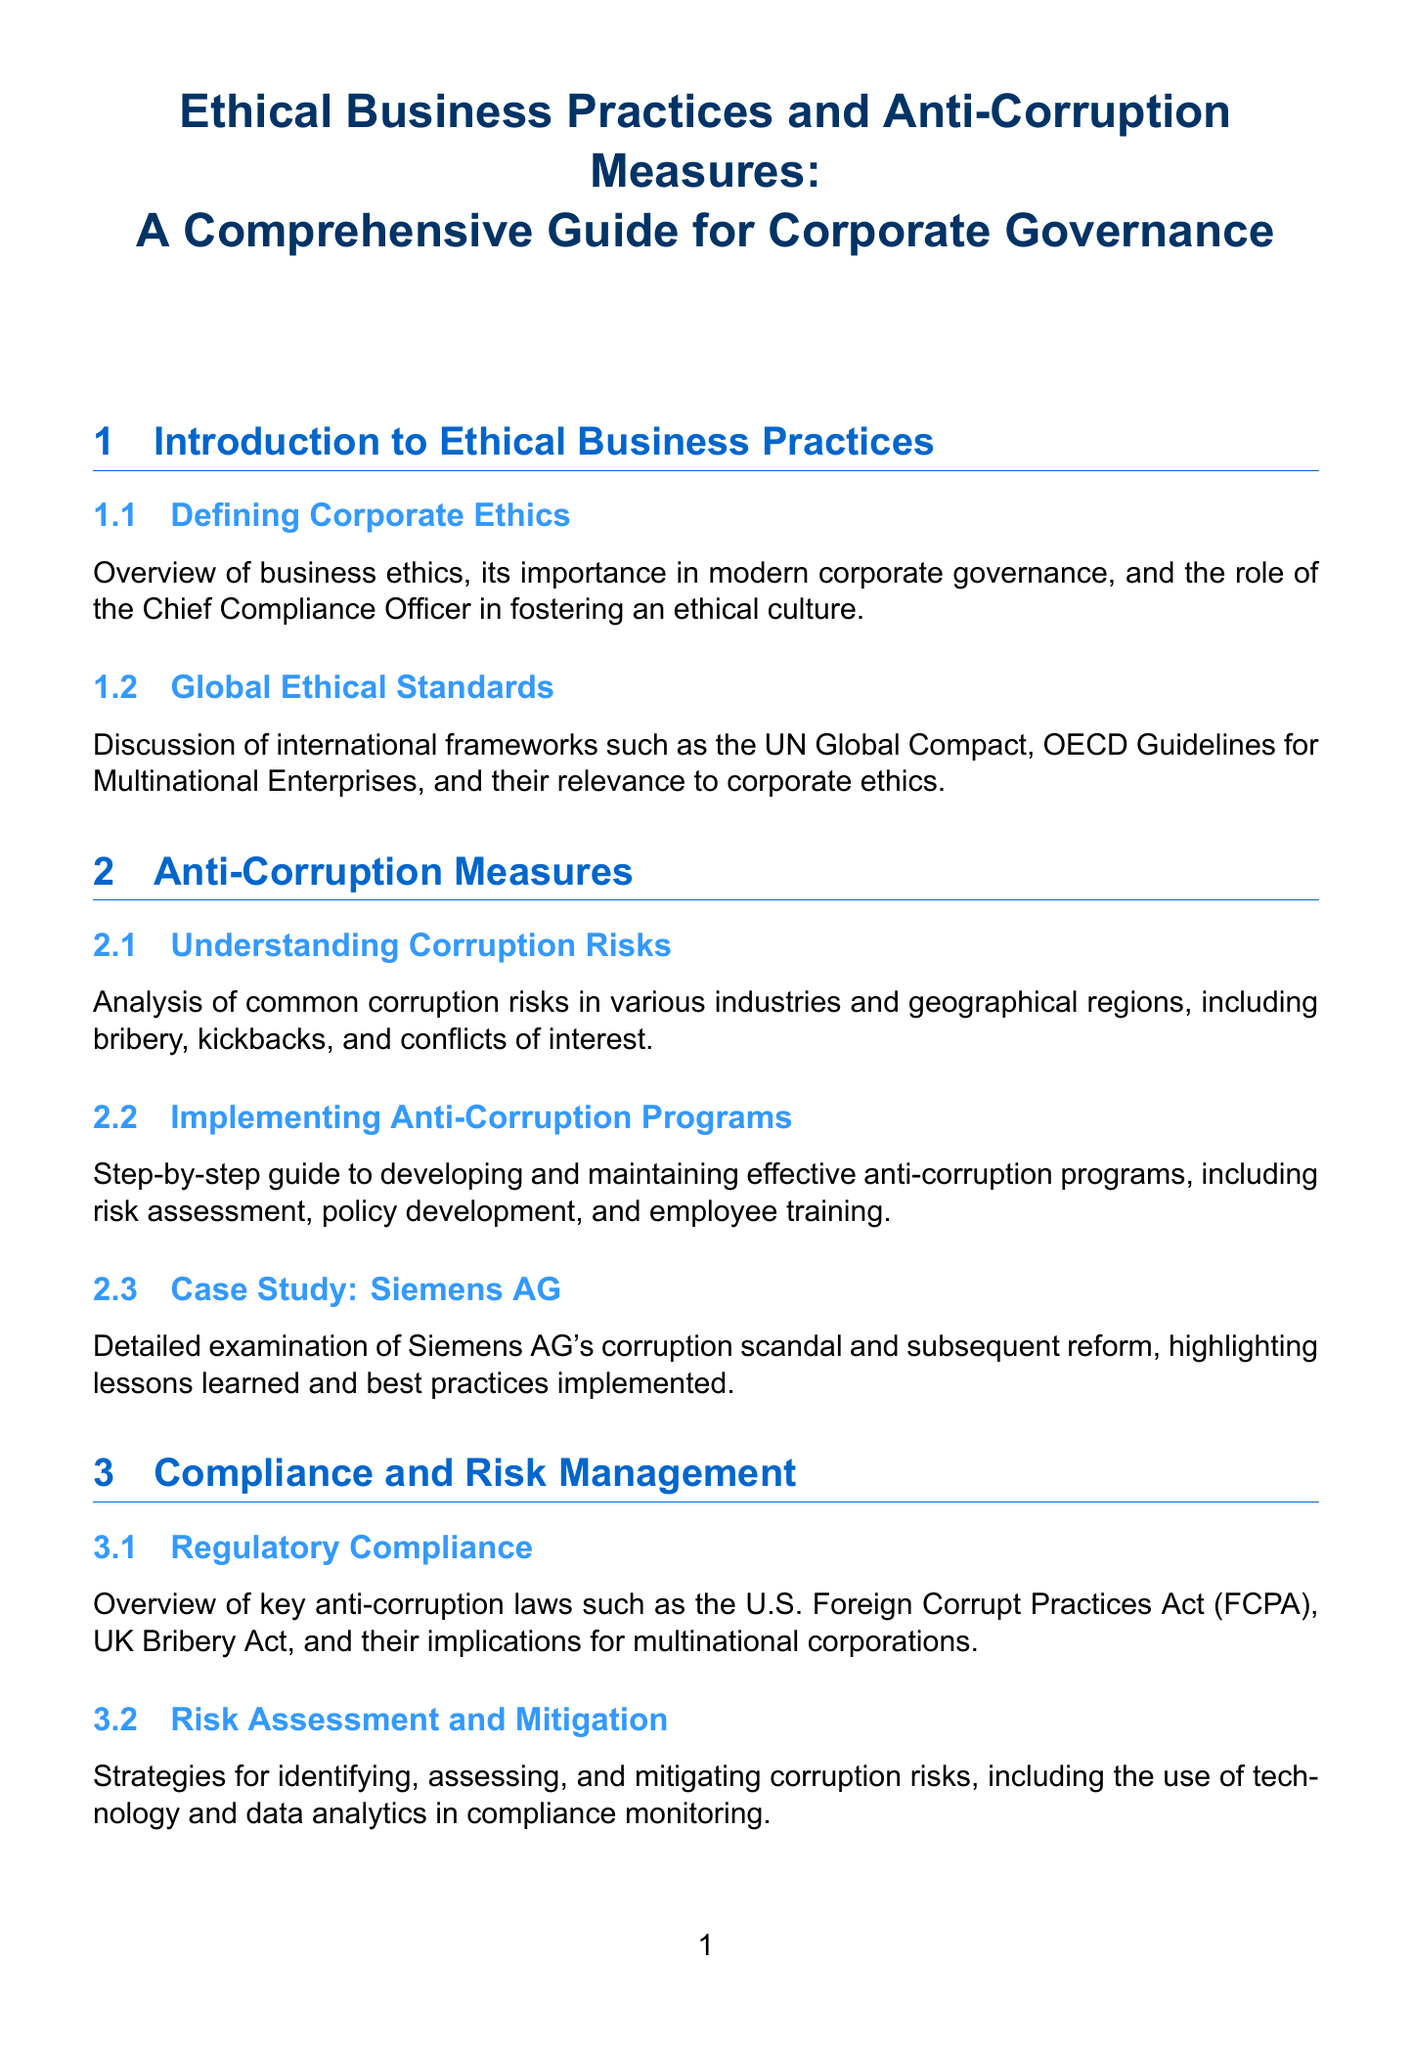What is the title of the manual? The title of the manual is explicitly mentioned at the beginning of the document.
Answer: Ethical Business Practices and Anti-Corruption Measures: A Comprehensive Guide for Corporate Governance How many sections are in the manual? The number of sections can be counted from the document's structure, which lists each main area of focus.
Answer: Six What case study is related to Siemens? The document specifically mentions a case study focusing on Siemens AG's experiences with corruption issues.
Answer: Siemens AG What is the first subsection of the introduction? The first subsection is specified in the introduction section of the document.
Answer: Defining Corporate Ethics Which act is highlighted in the regulatory compliance section? The regulatory compliance section references significant legislation relevant to anti-corruption measures.
Answer: U.S. Foreign Corrupt Practices Act What company is examined in the case study regarding internal investigations? A case study is included that focuses on a particular corporation’s experience with whistleblowing issues.
Answer: Olympus Corporation What framework is discussed under ethical reporting standards? The document mentions a widely recognized framework related to sustainability and corporate responsibility reporting.
Answer: Global Reporting Initiative What topic does the appendix A cover? Appendix A outlines a specific resource intended to assist organizations in establishing ethical guidelines.
Answer: Sample Code of Conduct Which company's ethical business model is featured as a case study? The document highlights a specific company known for its commitment to ethical practices, serving as an example.
Answer: Patagonia 